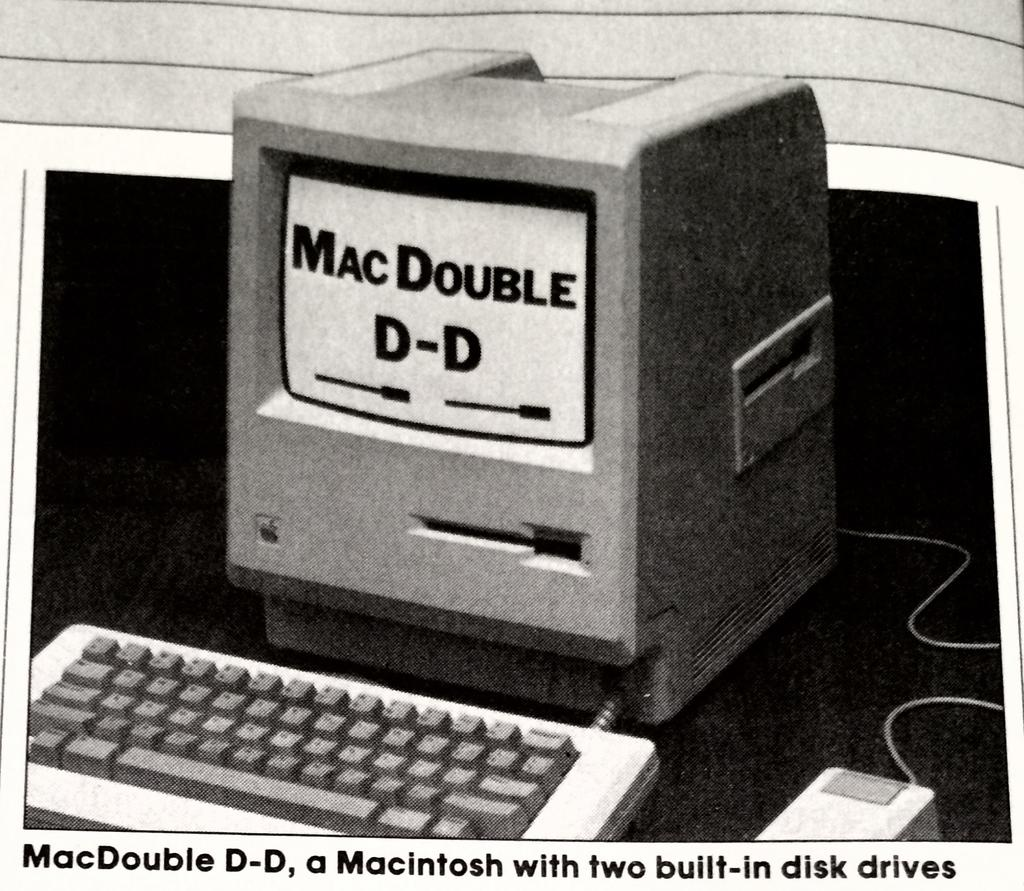<image>
Describe the image concisely. An old computer with the words "MacDOuble D-D" on the screen. 